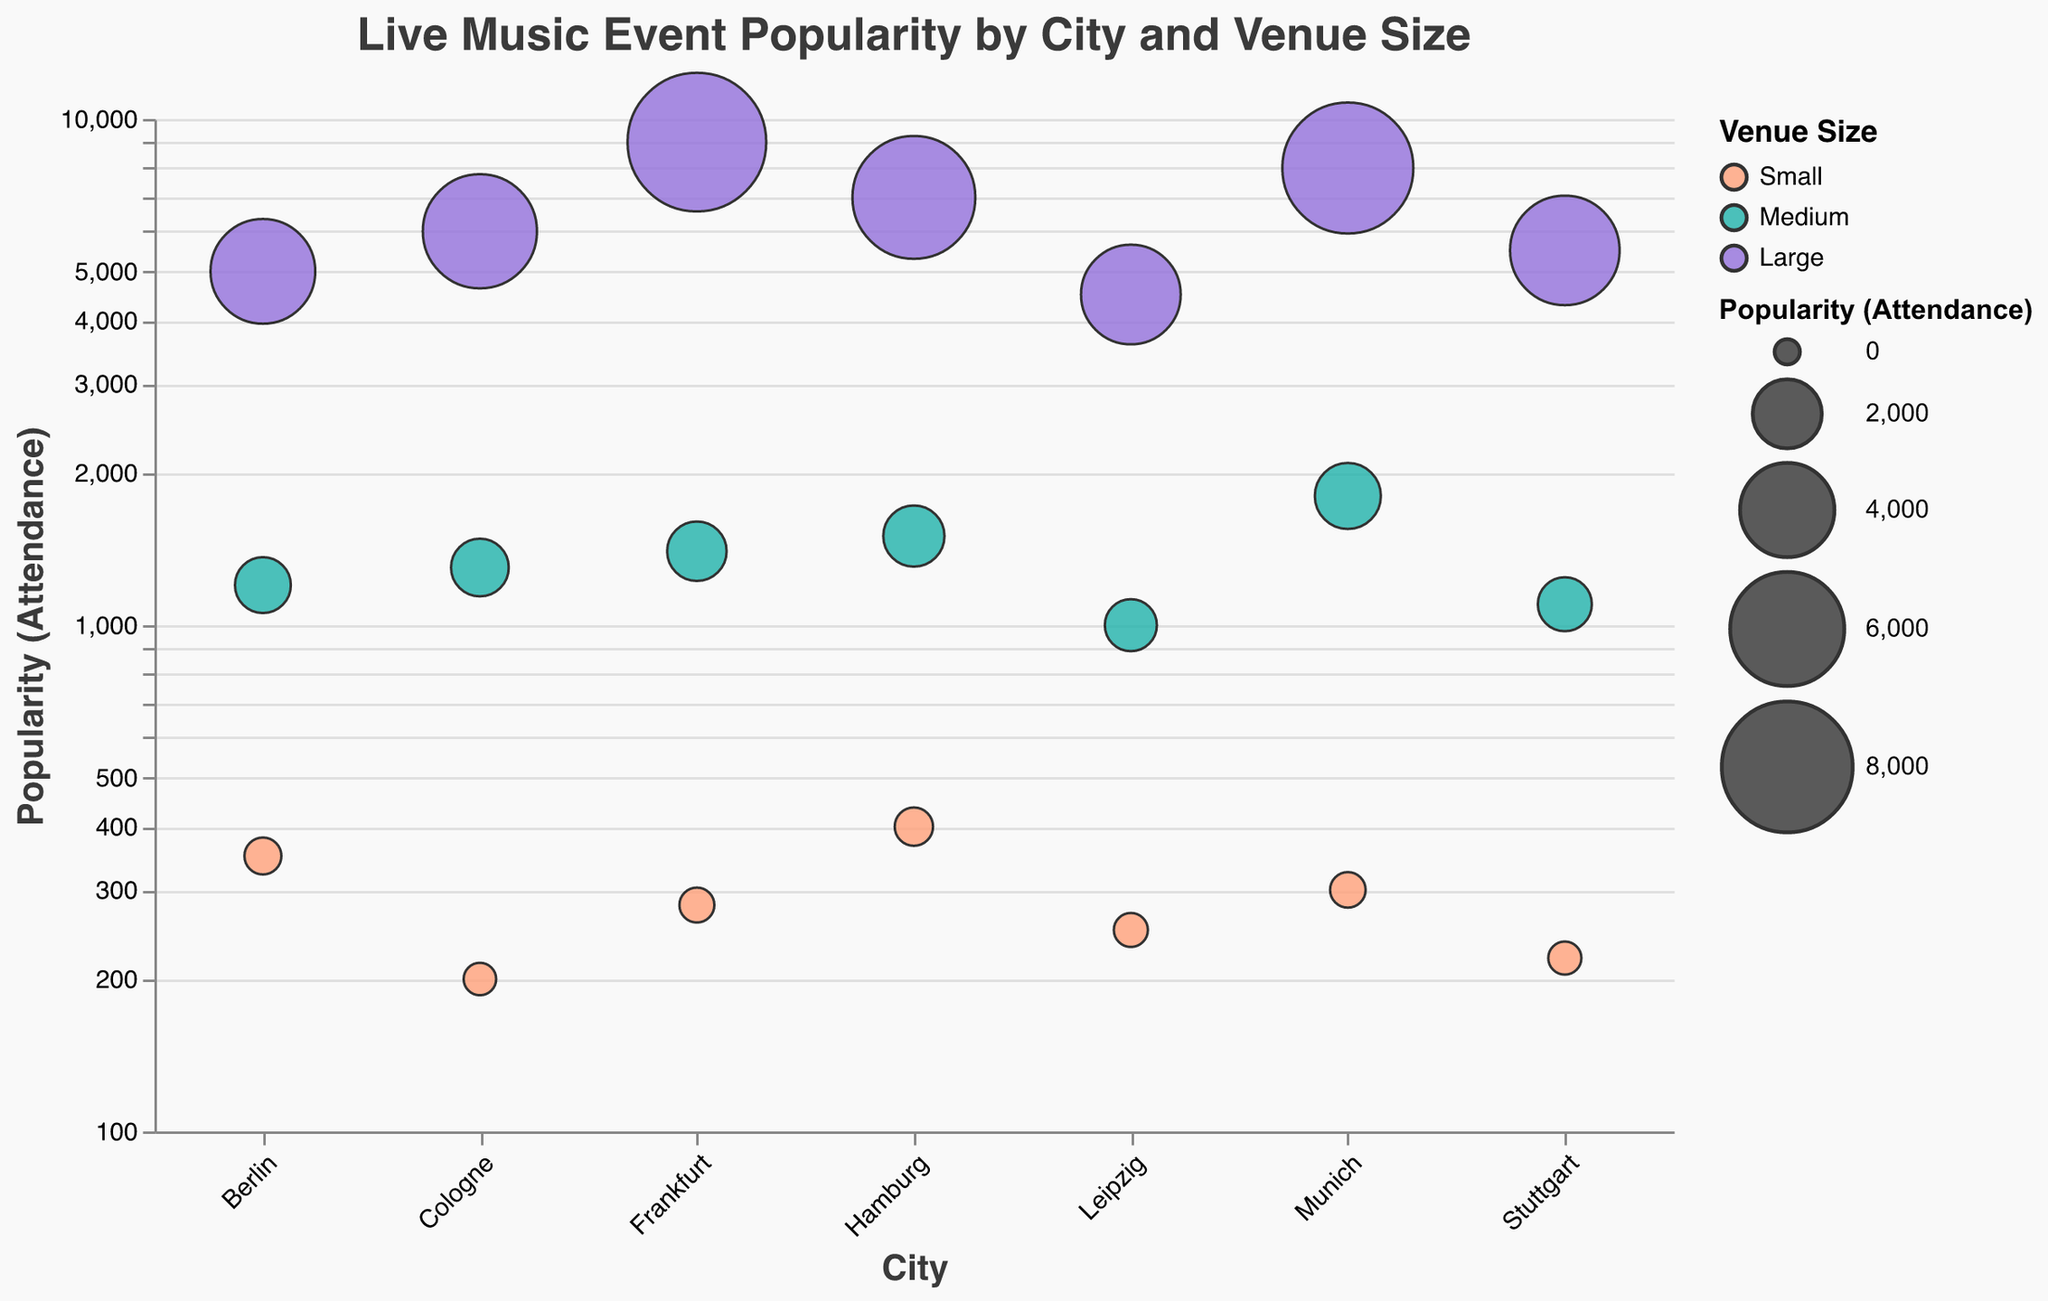Which city has the venue with the highest attendance? To find the city with the highest attendance, look at the "Popularity (Attendance)" axis for the highest value and identify the corresponding city at the "City" axis. The highest attendance is 9000, which is in Frankfurt.
Answer: Frankfurt Which venue size has the highest average popularity across all cities? Calculate the average popularity for each venue size category: Small, Medium, and Large. Sum the popularity values for all entries in each category and divide by the number of venues in that category. Large venues have the highest average popularity.
Answer: Large How many cities have at least one venue with an attendance of over 5000? Identify cities with at least one venue that has popularity (attendance) greater than 5000. These cities are Berlin, Hamburg, Munich, Cologne, Stuttgart, and Frankfurt. There are 6 such cities.
Answer: 6 Which city has the smallest event popularity in a small venue? Look at the "Venue Size" categorized by "Small" and identify the city with the lowest "Popularity (Attendance)". The smallest attendance for Small venues is 200, located in Cologne.
Answer: Cologne Compare the popularity of large venues between Berlin and Munich. Which one has higher attendance? Compare the "Popularity (Attendance)" values for large venues in Berlin and Munich. Berlin has 5000 and Munich has 8000. Munich has higher attendance for large venues.
Answer: Munich What is the attendance difference between the smallest small venue and the largest small venue? Find the smallest value in "Small" venues and the largest value in "Small" venues, then calculate the difference. Smallest is 200 (Cologne), largest is 400 (Hamburg). The difference is 400 - 200 = 200.
Answer: 200 How many medium-sized venues are there in total? Count the number of data points categorized under "Medium" in the "Venue Size". From the data, there are 6 medium-sized venues (one in each city).
Answer: 6 What is the total attendance across all large venues? Sum up the "Popularity (Attendance)" values for all entries categorized as "Large". The total is 5000 + 7000 + 8000 + 6000 + 4500 + 5500 + 9000 = 45000.
Answer: 45000 